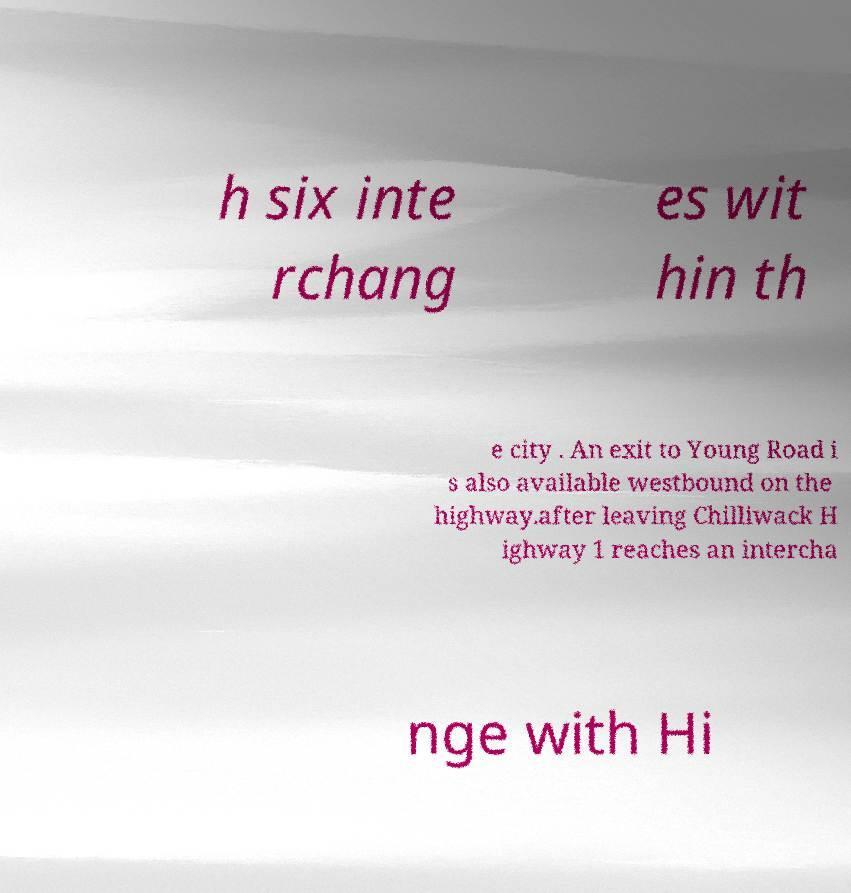Can you read and provide the text displayed in the image?This photo seems to have some interesting text. Can you extract and type it out for me? h six inte rchang es wit hin th e city . An exit to Young Road i s also available westbound on the highway.after leaving Chilliwack H ighway 1 reaches an intercha nge with Hi 